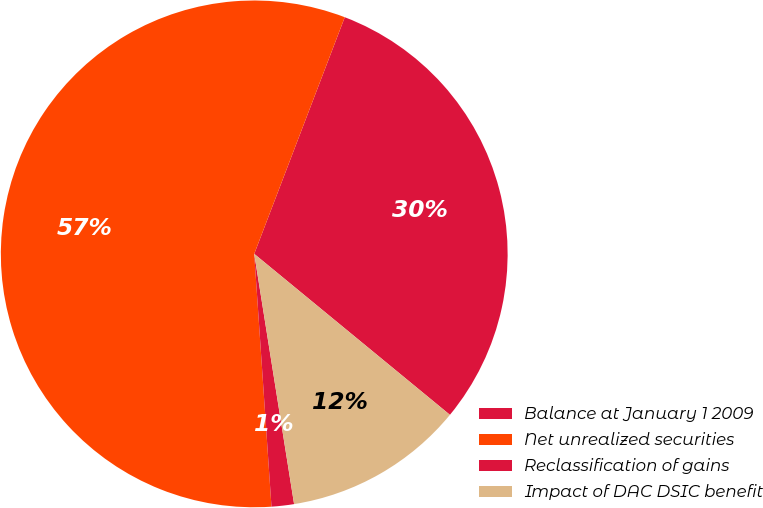Convert chart. <chart><loc_0><loc_0><loc_500><loc_500><pie_chart><fcel>Balance at January 1 2009<fcel>Net unrealized securities<fcel>Reclassification of gains<fcel>Impact of DAC DSIC benefit<nl><fcel>30.14%<fcel>56.9%<fcel>1.43%<fcel>11.53%<nl></chart> 